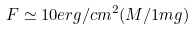Convert formula to latex. <formula><loc_0><loc_0><loc_500><loc_500>F \simeq 1 0 e r g / c m ^ { 2 } ( M / 1 m g )</formula> 